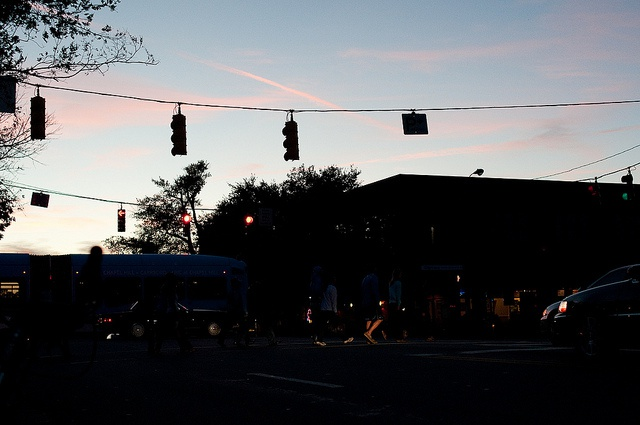Describe the objects in this image and their specific colors. I can see bus in black, beige, gray, and tan tones, car in black, gray, darkblue, and blue tones, car in black, maroon, and gray tones, people in black, teal, and maroon tones, and people in black, maroon, and brown tones in this image. 